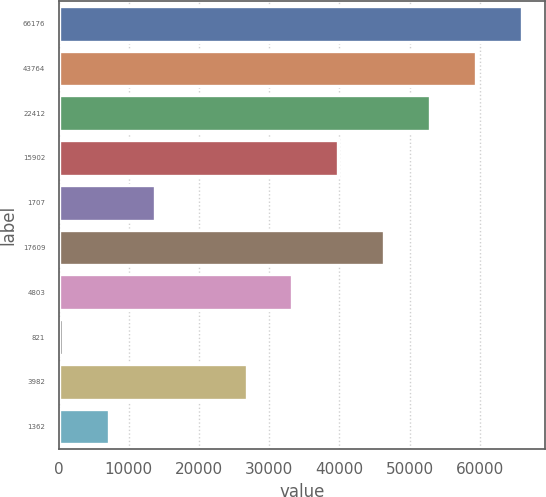Convert chart. <chart><loc_0><loc_0><loc_500><loc_500><bar_chart><fcel>66176<fcel>43764<fcel>22412<fcel>15902<fcel>1707<fcel>17609<fcel>4803<fcel>821<fcel>3982<fcel>1362<nl><fcel>65955<fcel>59425.3<fcel>52895.6<fcel>39836.2<fcel>13717.4<fcel>46365.9<fcel>33306.5<fcel>658<fcel>26776.8<fcel>7187.7<nl></chart> 